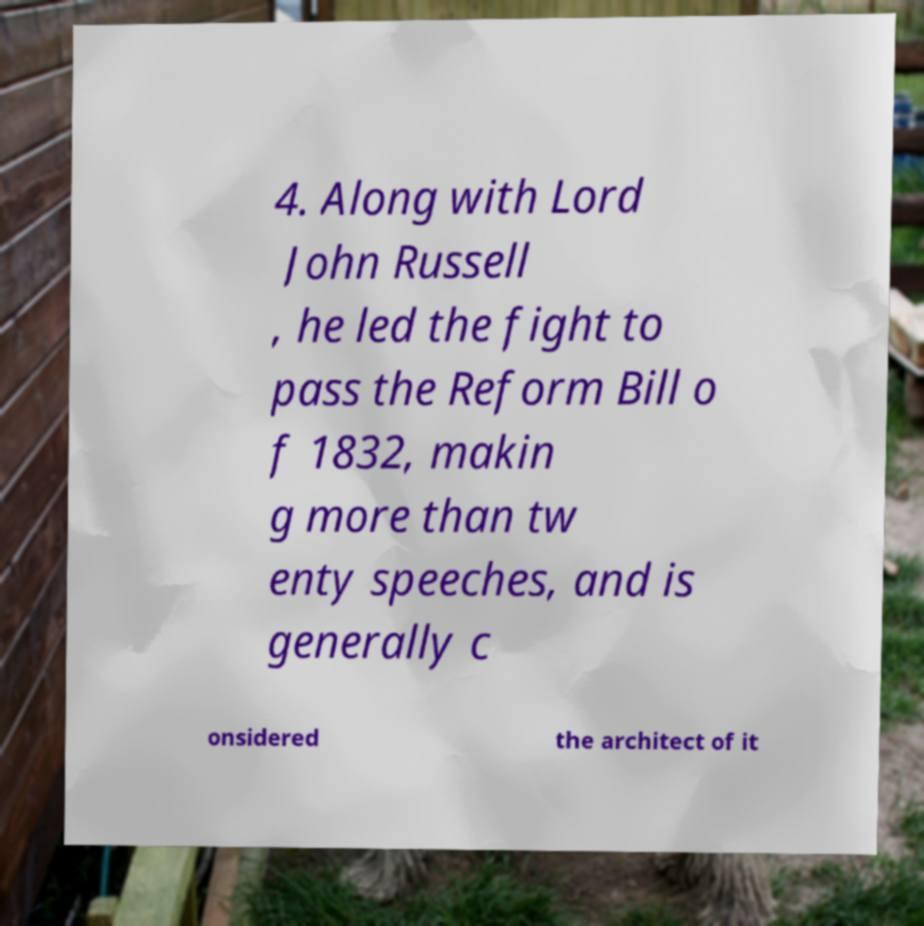Can you accurately transcribe the text from the provided image for me? 4. Along with Lord John Russell , he led the fight to pass the Reform Bill o f 1832, makin g more than tw enty speeches, and is generally c onsidered the architect of it 